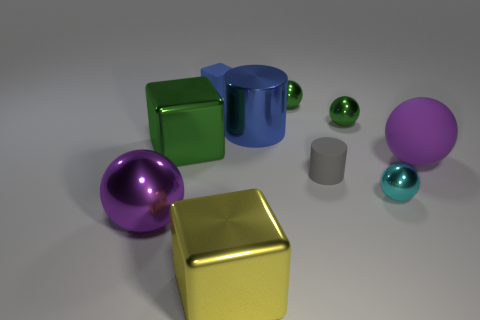What is the yellow cube made of?
Your answer should be very brief. Metal. Are there any purple things on the right side of the small cyan object?
Offer a terse response. Yes. What is the size of the yellow block that is the same material as the cyan thing?
Provide a short and direct response. Large. How many large cylinders are the same color as the rubber cube?
Offer a terse response. 1. Are there fewer tiny gray rubber cylinders that are right of the small cyan object than big metal objects right of the purple shiny object?
Your response must be concise. Yes. There is a green thing to the left of the blue metallic cylinder; what is its size?
Give a very brief answer. Large. What size is the cube that is the same color as the large shiny cylinder?
Give a very brief answer. Small. Is there a big green cube that has the same material as the small cube?
Provide a succinct answer. No. Are the cyan object and the big green cube made of the same material?
Provide a short and direct response. Yes. What color is the cylinder that is the same size as the cyan object?
Ensure brevity in your answer.  Gray. 